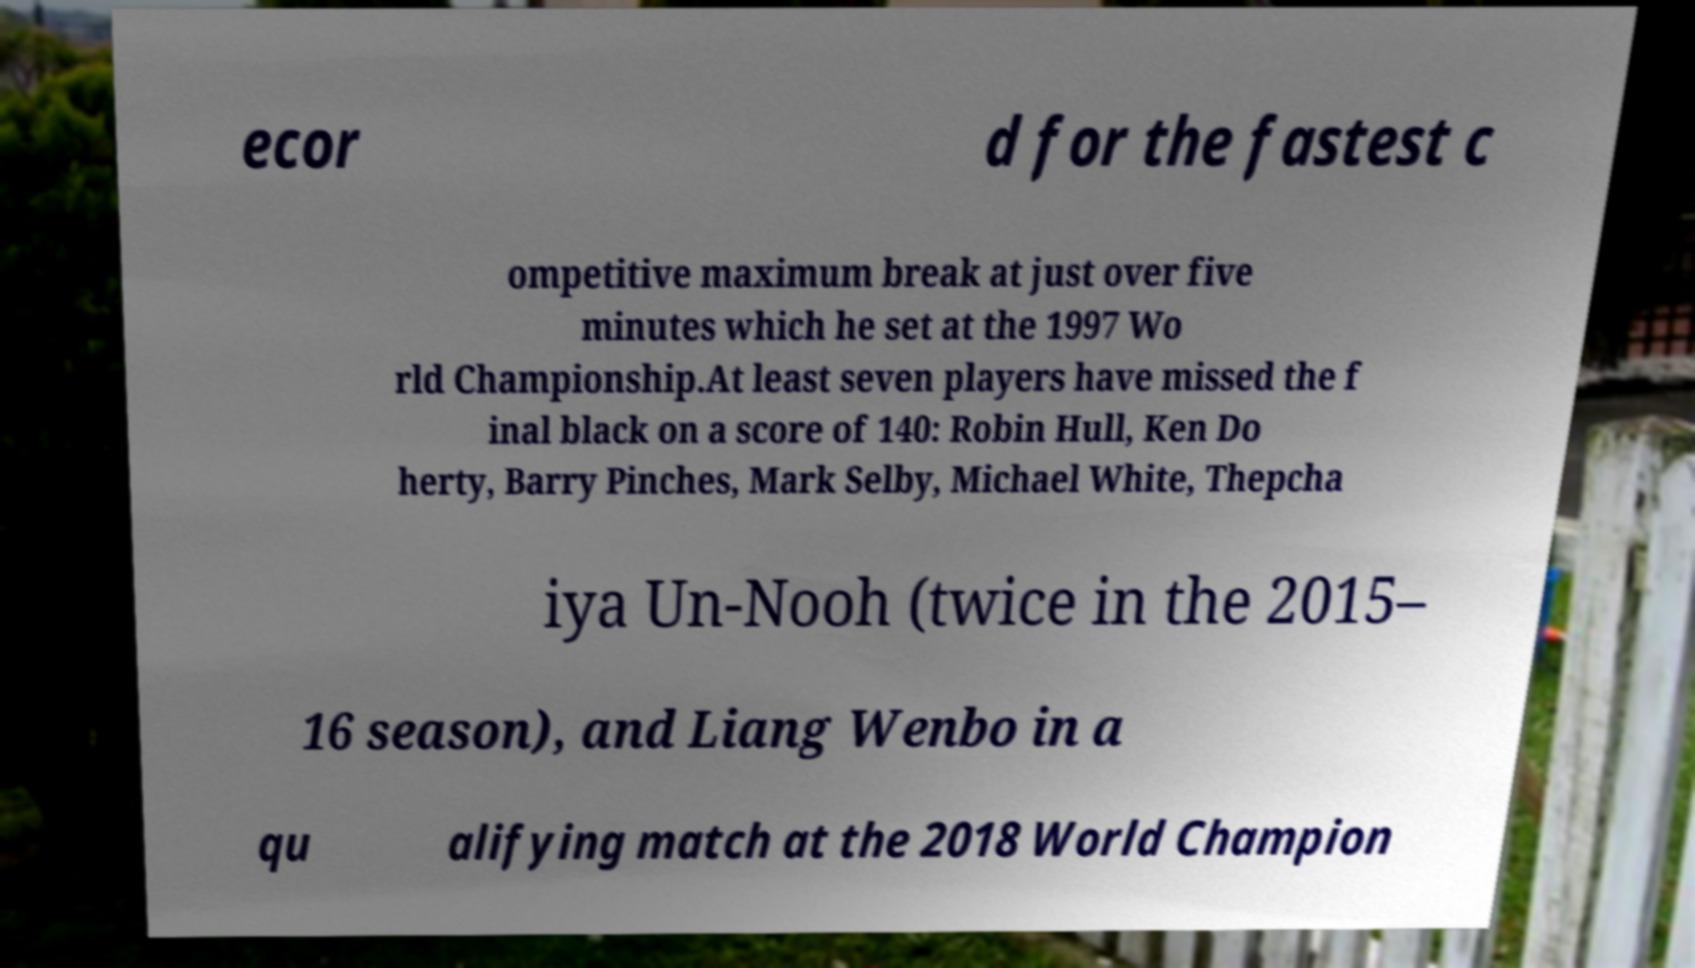I need the written content from this picture converted into text. Can you do that? ecor d for the fastest c ompetitive maximum break at just over five minutes which he set at the 1997 Wo rld Championship.At least seven players have missed the f inal black on a score of 140: Robin Hull, Ken Do herty, Barry Pinches, Mark Selby, Michael White, Thepcha iya Un-Nooh (twice in the 2015– 16 season), and Liang Wenbo in a qu alifying match at the 2018 World Champion 